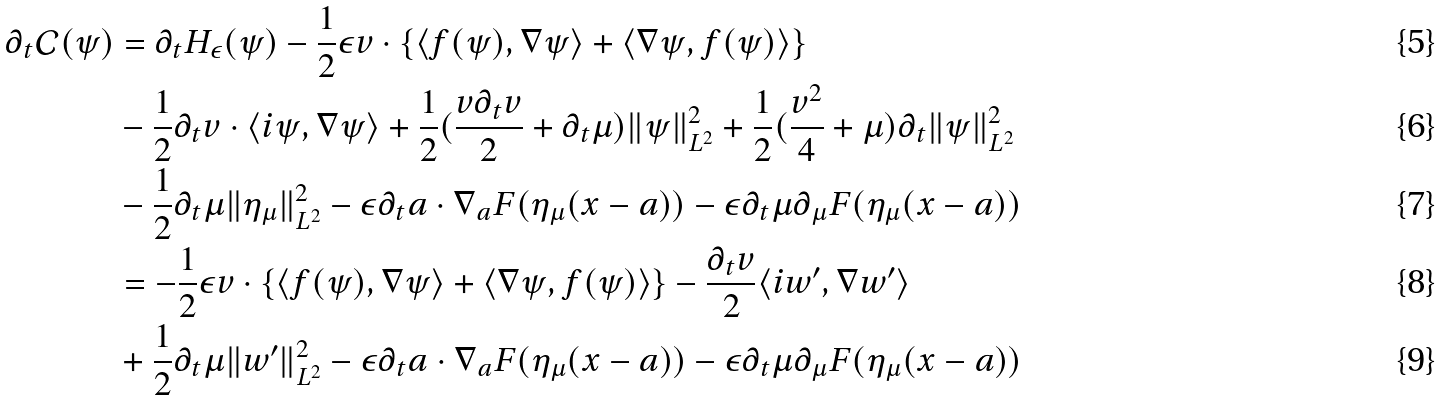<formula> <loc_0><loc_0><loc_500><loc_500>\partial _ { t } { \mathcal { C } } ( \psi ) & = \partial _ { t } H _ { \epsilon } ( \psi ) - \frac { 1 } { 2 } \epsilon v \cdot \{ \langle f ( \psi ) , \nabla \psi \rangle + \langle \nabla \psi , f ( \psi ) \rangle \} \\ & - \frac { 1 } { 2 } \partial _ { t } v \cdot \langle i \psi , \nabla \psi \rangle + \frac { 1 } { 2 } ( \frac { v \partial _ { t } v } { 2 } + \partial _ { t } \mu ) \| \psi \| _ { L ^ { 2 } } ^ { 2 } + \frac { 1 } { 2 } ( \frac { v ^ { 2 } } { 4 } + \mu ) \partial _ { t } \| \psi \| _ { L ^ { 2 } } ^ { 2 } \\ & - \frac { 1 } { 2 } \partial _ { t } \mu \| \eta _ { \mu } \| _ { L ^ { 2 } } ^ { 2 } - \epsilon \partial _ { t } a \cdot \nabla _ { a } F ( \eta _ { \mu } ( x - a ) ) - \epsilon \partial _ { t } \mu \partial _ { \mu } F ( \eta _ { \mu } ( x - a ) ) \\ & = - \frac { 1 } { 2 } \epsilon v \cdot \{ \langle f ( \psi ) , \nabla \psi \rangle + \langle \nabla \psi , f ( \psi ) \rangle \} - \frac { \partial _ { t } v } { 2 } \langle i w ^ { \prime } , \nabla w ^ { \prime } \rangle \\ & + \frac { 1 } { 2 } \partial _ { t } \mu \| w ^ { \prime } \| _ { L ^ { 2 } } ^ { 2 } - \epsilon \partial _ { t } a \cdot \nabla _ { a } F ( \eta _ { \mu } ( x - a ) ) - \epsilon \partial _ { t } \mu \partial _ { \mu } F ( \eta _ { \mu } ( x - a ) )</formula> 